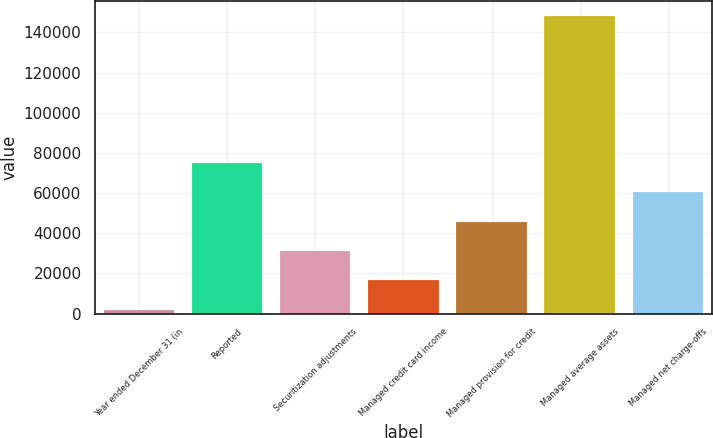Convert chart. <chart><loc_0><loc_0><loc_500><loc_500><bar_chart><fcel>Year ended December 31 (in<fcel>Reported<fcel>Securitization adjustments<fcel>Managed credit card income<fcel>Managed provision for credit<fcel>Managed average assets<fcel>Managed net charge-offs<nl><fcel>2006<fcel>75079.5<fcel>31235.4<fcel>16620.7<fcel>45850.1<fcel>148153<fcel>60464.8<nl></chart> 